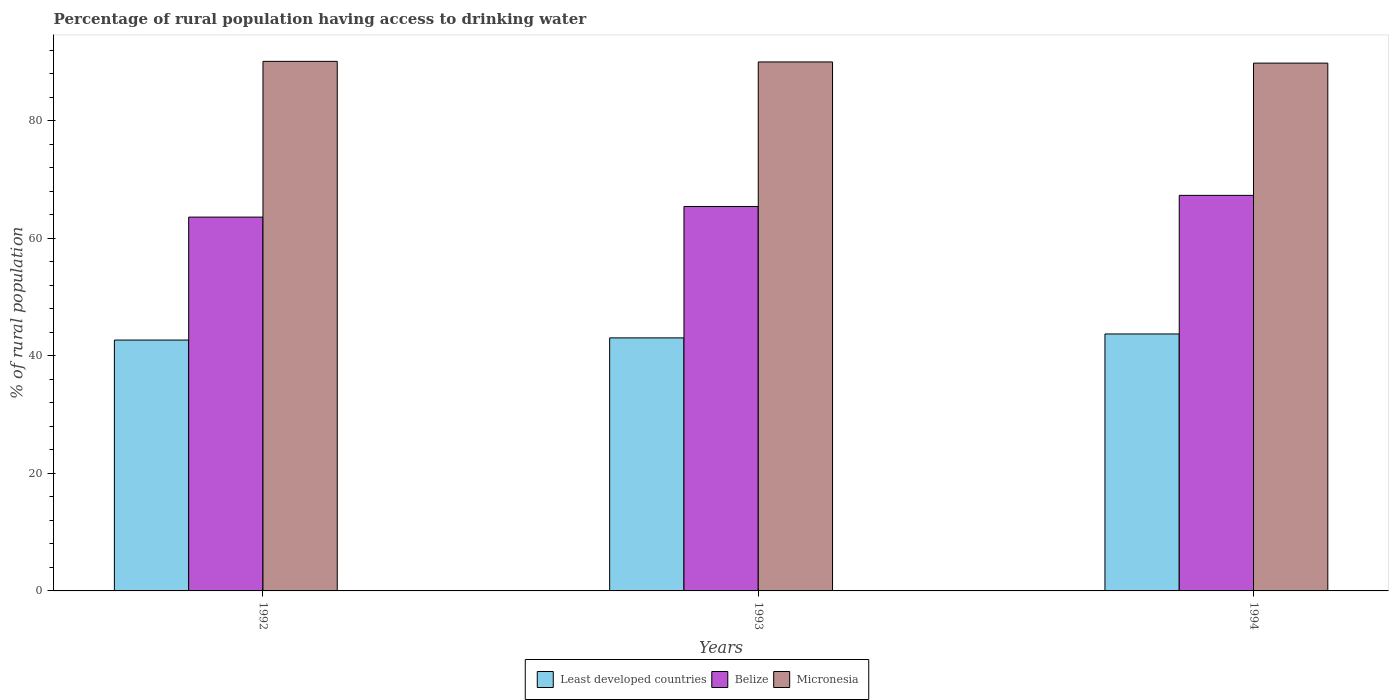How many groups of bars are there?
Ensure brevity in your answer.  3. How many bars are there on the 2nd tick from the right?
Ensure brevity in your answer.  3. What is the label of the 2nd group of bars from the left?
Your response must be concise. 1993. What is the percentage of rural population having access to drinking water in Micronesia in 1992?
Make the answer very short. 90.1. Across all years, what is the maximum percentage of rural population having access to drinking water in Belize?
Offer a very short reply. 67.3. Across all years, what is the minimum percentage of rural population having access to drinking water in Least developed countries?
Provide a short and direct response. 42.68. What is the total percentage of rural population having access to drinking water in Micronesia in the graph?
Ensure brevity in your answer.  269.9. What is the difference between the percentage of rural population having access to drinking water in Belize in 1993 and that in 1994?
Your response must be concise. -1.9. What is the difference between the percentage of rural population having access to drinking water in Micronesia in 1993 and the percentage of rural population having access to drinking water in Least developed countries in 1994?
Your response must be concise. 46.28. What is the average percentage of rural population having access to drinking water in Belize per year?
Make the answer very short. 65.43. In the year 1994, what is the difference between the percentage of rural population having access to drinking water in Belize and percentage of rural population having access to drinking water in Least developed countries?
Keep it short and to the point. 23.58. In how many years, is the percentage of rural population having access to drinking water in Least developed countries greater than 52 %?
Give a very brief answer. 0. What is the ratio of the percentage of rural population having access to drinking water in Micronesia in 1992 to that in 1993?
Offer a terse response. 1. What is the difference between the highest and the second highest percentage of rural population having access to drinking water in Least developed countries?
Offer a very short reply. 0.67. What is the difference between the highest and the lowest percentage of rural population having access to drinking water in Least developed countries?
Your answer should be compact. 1.04. In how many years, is the percentage of rural population having access to drinking water in Least developed countries greater than the average percentage of rural population having access to drinking water in Least developed countries taken over all years?
Your response must be concise. 1. Is the sum of the percentage of rural population having access to drinking water in Least developed countries in 1992 and 1994 greater than the maximum percentage of rural population having access to drinking water in Micronesia across all years?
Ensure brevity in your answer.  No. What does the 2nd bar from the left in 1993 represents?
Ensure brevity in your answer.  Belize. What does the 3rd bar from the right in 1993 represents?
Give a very brief answer. Least developed countries. How many bars are there?
Offer a terse response. 9. What is the difference between two consecutive major ticks on the Y-axis?
Make the answer very short. 20. Are the values on the major ticks of Y-axis written in scientific E-notation?
Provide a succinct answer. No. Does the graph contain any zero values?
Your answer should be very brief. No. Does the graph contain grids?
Keep it short and to the point. No. How many legend labels are there?
Your answer should be very brief. 3. What is the title of the graph?
Your answer should be compact. Percentage of rural population having access to drinking water. What is the label or title of the X-axis?
Keep it short and to the point. Years. What is the label or title of the Y-axis?
Your answer should be compact. % of rural population. What is the % of rural population of Least developed countries in 1992?
Keep it short and to the point. 42.68. What is the % of rural population of Belize in 1992?
Offer a terse response. 63.6. What is the % of rural population in Micronesia in 1992?
Keep it short and to the point. 90.1. What is the % of rural population in Least developed countries in 1993?
Offer a very short reply. 43.05. What is the % of rural population in Belize in 1993?
Provide a succinct answer. 65.4. What is the % of rural population of Least developed countries in 1994?
Your answer should be compact. 43.72. What is the % of rural population of Belize in 1994?
Ensure brevity in your answer.  67.3. What is the % of rural population of Micronesia in 1994?
Make the answer very short. 89.8. Across all years, what is the maximum % of rural population in Least developed countries?
Offer a terse response. 43.72. Across all years, what is the maximum % of rural population in Belize?
Offer a terse response. 67.3. Across all years, what is the maximum % of rural population of Micronesia?
Your answer should be very brief. 90.1. Across all years, what is the minimum % of rural population in Least developed countries?
Your answer should be compact. 42.68. Across all years, what is the minimum % of rural population of Belize?
Offer a very short reply. 63.6. Across all years, what is the minimum % of rural population of Micronesia?
Your answer should be compact. 89.8. What is the total % of rural population of Least developed countries in the graph?
Your response must be concise. 129.45. What is the total % of rural population in Belize in the graph?
Ensure brevity in your answer.  196.3. What is the total % of rural population in Micronesia in the graph?
Give a very brief answer. 269.9. What is the difference between the % of rural population of Least developed countries in 1992 and that in 1993?
Make the answer very short. -0.37. What is the difference between the % of rural population in Micronesia in 1992 and that in 1993?
Provide a short and direct response. 0.1. What is the difference between the % of rural population of Least developed countries in 1992 and that in 1994?
Keep it short and to the point. -1.04. What is the difference between the % of rural population in Belize in 1992 and that in 1994?
Make the answer very short. -3.7. What is the difference between the % of rural population in Micronesia in 1992 and that in 1994?
Provide a short and direct response. 0.3. What is the difference between the % of rural population in Least developed countries in 1993 and that in 1994?
Your answer should be compact. -0.67. What is the difference between the % of rural population in Micronesia in 1993 and that in 1994?
Offer a terse response. 0.2. What is the difference between the % of rural population of Least developed countries in 1992 and the % of rural population of Belize in 1993?
Offer a terse response. -22.72. What is the difference between the % of rural population of Least developed countries in 1992 and the % of rural population of Micronesia in 1993?
Provide a short and direct response. -47.32. What is the difference between the % of rural population of Belize in 1992 and the % of rural population of Micronesia in 1993?
Make the answer very short. -26.4. What is the difference between the % of rural population in Least developed countries in 1992 and the % of rural population in Belize in 1994?
Offer a very short reply. -24.62. What is the difference between the % of rural population in Least developed countries in 1992 and the % of rural population in Micronesia in 1994?
Your answer should be compact. -47.12. What is the difference between the % of rural population in Belize in 1992 and the % of rural population in Micronesia in 1994?
Ensure brevity in your answer.  -26.2. What is the difference between the % of rural population of Least developed countries in 1993 and the % of rural population of Belize in 1994?
Your answer should be compact. -24.25. What is the difference between the % of rural population of Least developed countries in 1993 and the % of rural population of Micronesia in 1994?
Keep it short and to the point. -46.75. What is the difference between the % of rural population of Belize in 1993 and the % of rural population of Micronesia in 1994?
Your response must be concise. -24.4. What is the average % of rural population in Least developed countries per year?
Your response must be concise. 43.15. What is the average % of rural population in Belize per year?
Keep it short and to the point. 65.43. What is the average % of rural population in Micronesia per year?
Your answer should be compact. 89.97. In the year 1992, what is the difference between the % of rural population in Least developed countries and % of rural population in Belize?
Offer a very short reply. -20.92. In the year 1992, what is the difference between the % of rural population of Least developed countries and % of rural population of Micronesia?
Keep it short and to the point. -47.42. In the year 1992, what is the difference between the % of rural population of Belize and % of rural population of Micronesia?
Offer a terse response. -26.5. In the year 1993, what is the difference between the % of rural population of Least developed countries and % of rural population of Belize?
Keep it short and to the point. -22.35. In the year 1993, what is the difference between the % of rural population of Least developed countries and % of rural population of Micronesia?
Offer a very short reply. -46.95. In the year 1993, what is the difference between the % of rural population in Belize and % of rural population in Micronesia?
Your answer should be compact. -24.6. In the year 1994, what is the difference between the % of rural population in Least developed countries and % of rural population in Belize?
Provide a short and direct response. -23.58. In the year 1994, what is the difference between the % of rural population in Least developed countries and % of rural population in Micronesia?
Ensure brevity in your answer.  -46.08. In the year 1994, what is the difference between the % of rural population in Belize and % of rural population in Micronesia?
Give a very brief answer. -22.5. What is the ratio of the % of rural population of Belize in 1992 to that in 1993?
Make the answer very short. 0.97. What is the ratio of the % of rural population of Least developed countries in 1992 to that in 1994?
Offer a very short reply. 0.98. What is the ratio of the % of rural population of Belize in 1992 to that in 1994?
Give a very brief answer. 0.94. What is the ratio of the % of rural population in Micronesia in 1992 to that in 1994?
Provide a short and direct response. 1. What is the ratio of the % of rural population in Least developed countries in 1993 to that in 1994?
Your answer should be very brief. 0.98. What is the ratio of the % of rural population in Belize in 1993 to that in 1994?
Provide a succinct answer. 0.97. What is the difference between the highest and the second highest % of rural population of Least developed countries?
Offer a very short reply. 0.67. What is the difference between the highest and the second highest % of rural population of Belize?
Your answer should be very brief. 1.9. What is the difference between the highest and the lowest % of rural population in Least developed countries?
Provide a short and direct response. 1.04. What is the difference between the highest and the lowest % of rural population in Belize?
Your answer should be very brief. 3.7. 